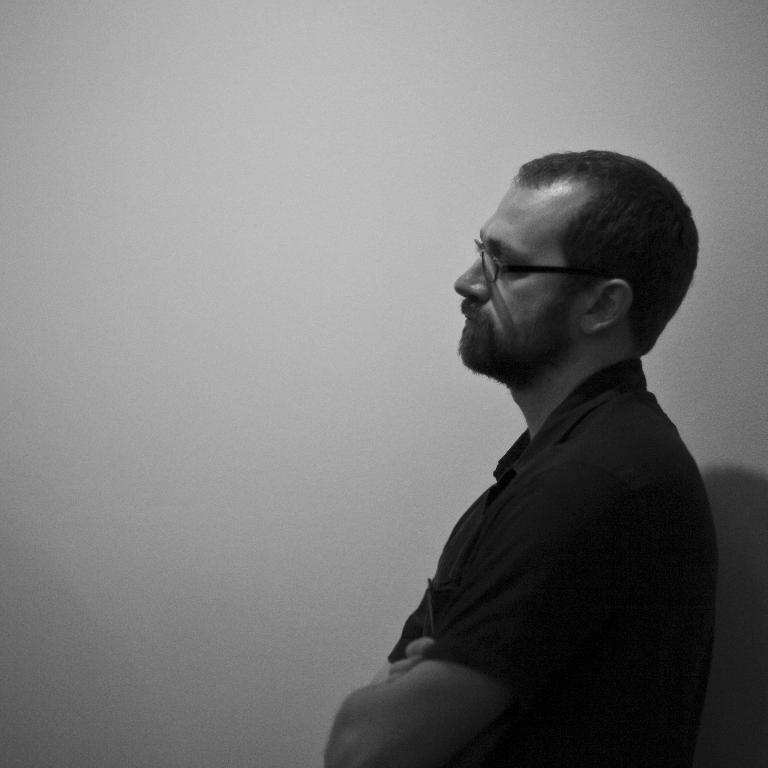What is the color scheme of the image? The image is black and white. Can you describe the person in the image? The person in the image is wearing glasses and a t-shirt. What is the person doing in the image? The person is standing. What can be seen in the background of the image? There is a wall in the background of the image. What type of lunch is the woman eating in the image? There is no woman present in the image, and no lunch can be seen. 